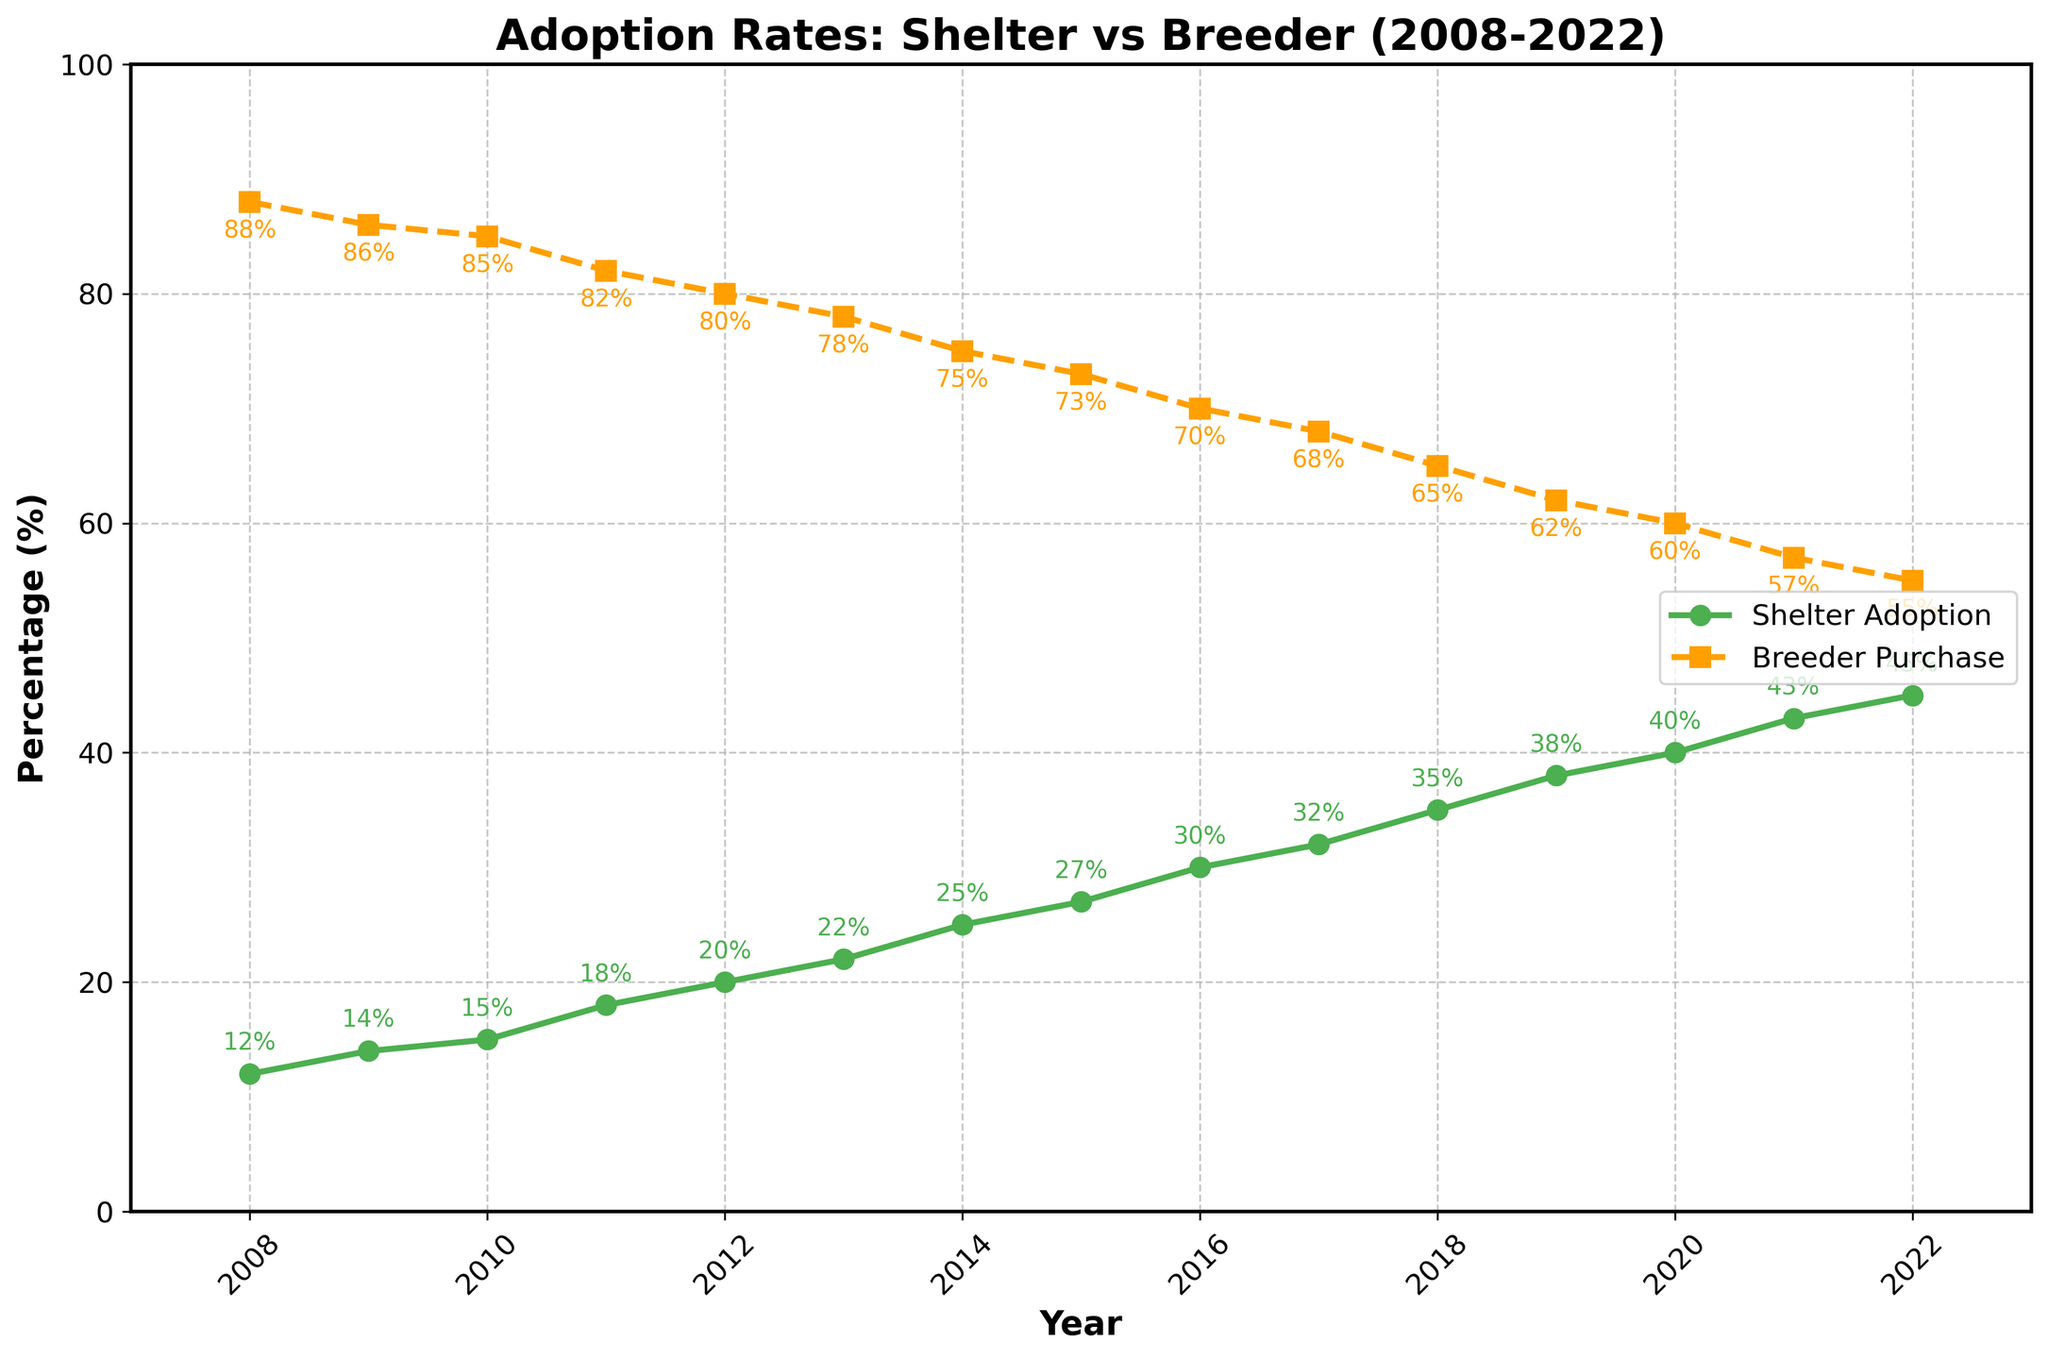Which year shows the highest shelter adoption rate? The green line representing Shelter Adoption reaches its highest point at 45% in 2022.
Answer: 2022 What is the percent difference in shelter adoptions between 2008 and 2022? Shelter adoptions in 2008 were 12%, and in 2022 they were 45%. The difference is 45% - 12% = 33%.
Answer: 33% How much did breeder purchases decline from 2008 to 2022? In 2008, breeder purchases were 88%, and in 2022 they were 55%. The decline is 88% - 55% = 33%.
Answer: 33% In which year did the shelter adoption rate first exceed 30%? The shelter adoption rate first exceeded 30% in 2016 where the adoption rate was 30%.
Answer: 2016 Compare the trend in shelter adoption rates to breeder purchase rates over the 15 years. The green line representing shelter adoptions shows a steady increase from 12% to 45%, while the orange dashed line for breeder purchases shows a steady decline from 88% to 55%.
Answer: Shelter adoption increased; breeder purchase declined Which line has a steeper slope between 2010 and 2012? From 2010 to 2012, the shelter adoption rate increased from 15% to 20%, a rise of 5%. In the same period, breeder purchases went from 85% to 80%, a drop of 5%. Both lines have the same change in value but different slopes due to differing initial percentages.
Answer: Both have the same change What is the overall trend in adoption rates from shelters? The green line for shelter adoptions trends steadily upward from 12% to 45% over 15 years.
Answer: Increasing During which year did the shelter adoption and breeder purchase lines intersect? The orange (breeder purchase) and green (shelter adoption) lines do not intersect at any point between 2008 and 2022.
Answer: No intersection What are the shelter adoption rates in the first and last years shown? The shelter adoption rate was 12% in 2008 and 45% in 2022.
Answer: 12% in 2008, 45% in 2022 